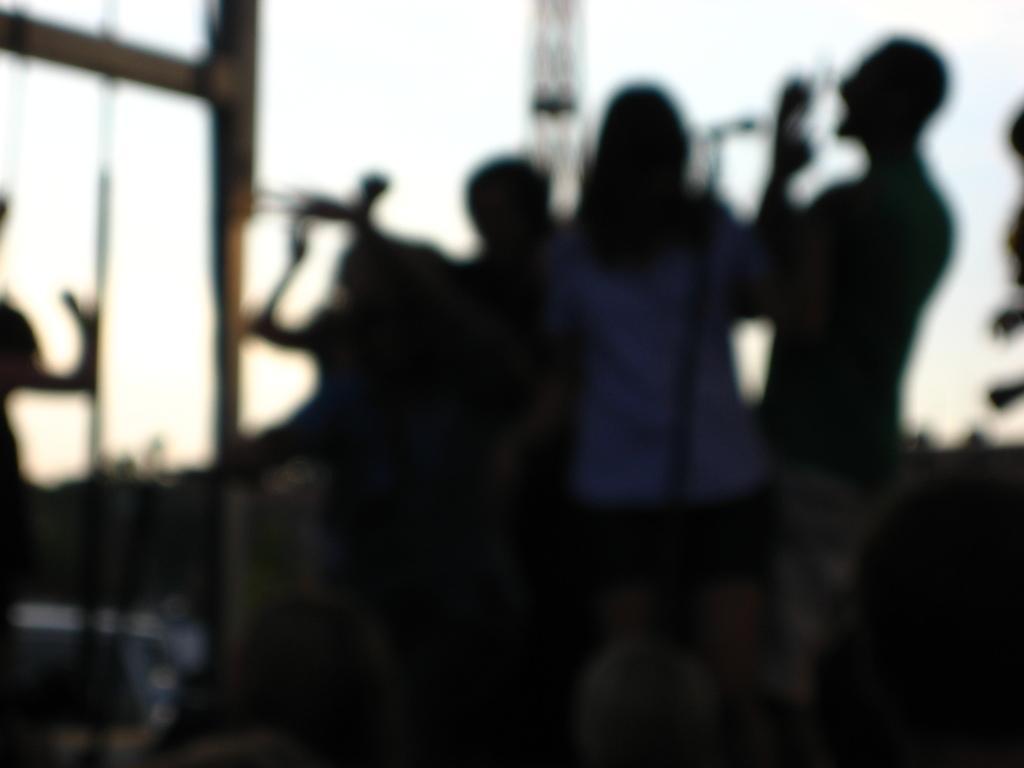Describe this image in one or two sentences. This image is blur. In this picture we can see some persons, mic, poles, tower, sky. 